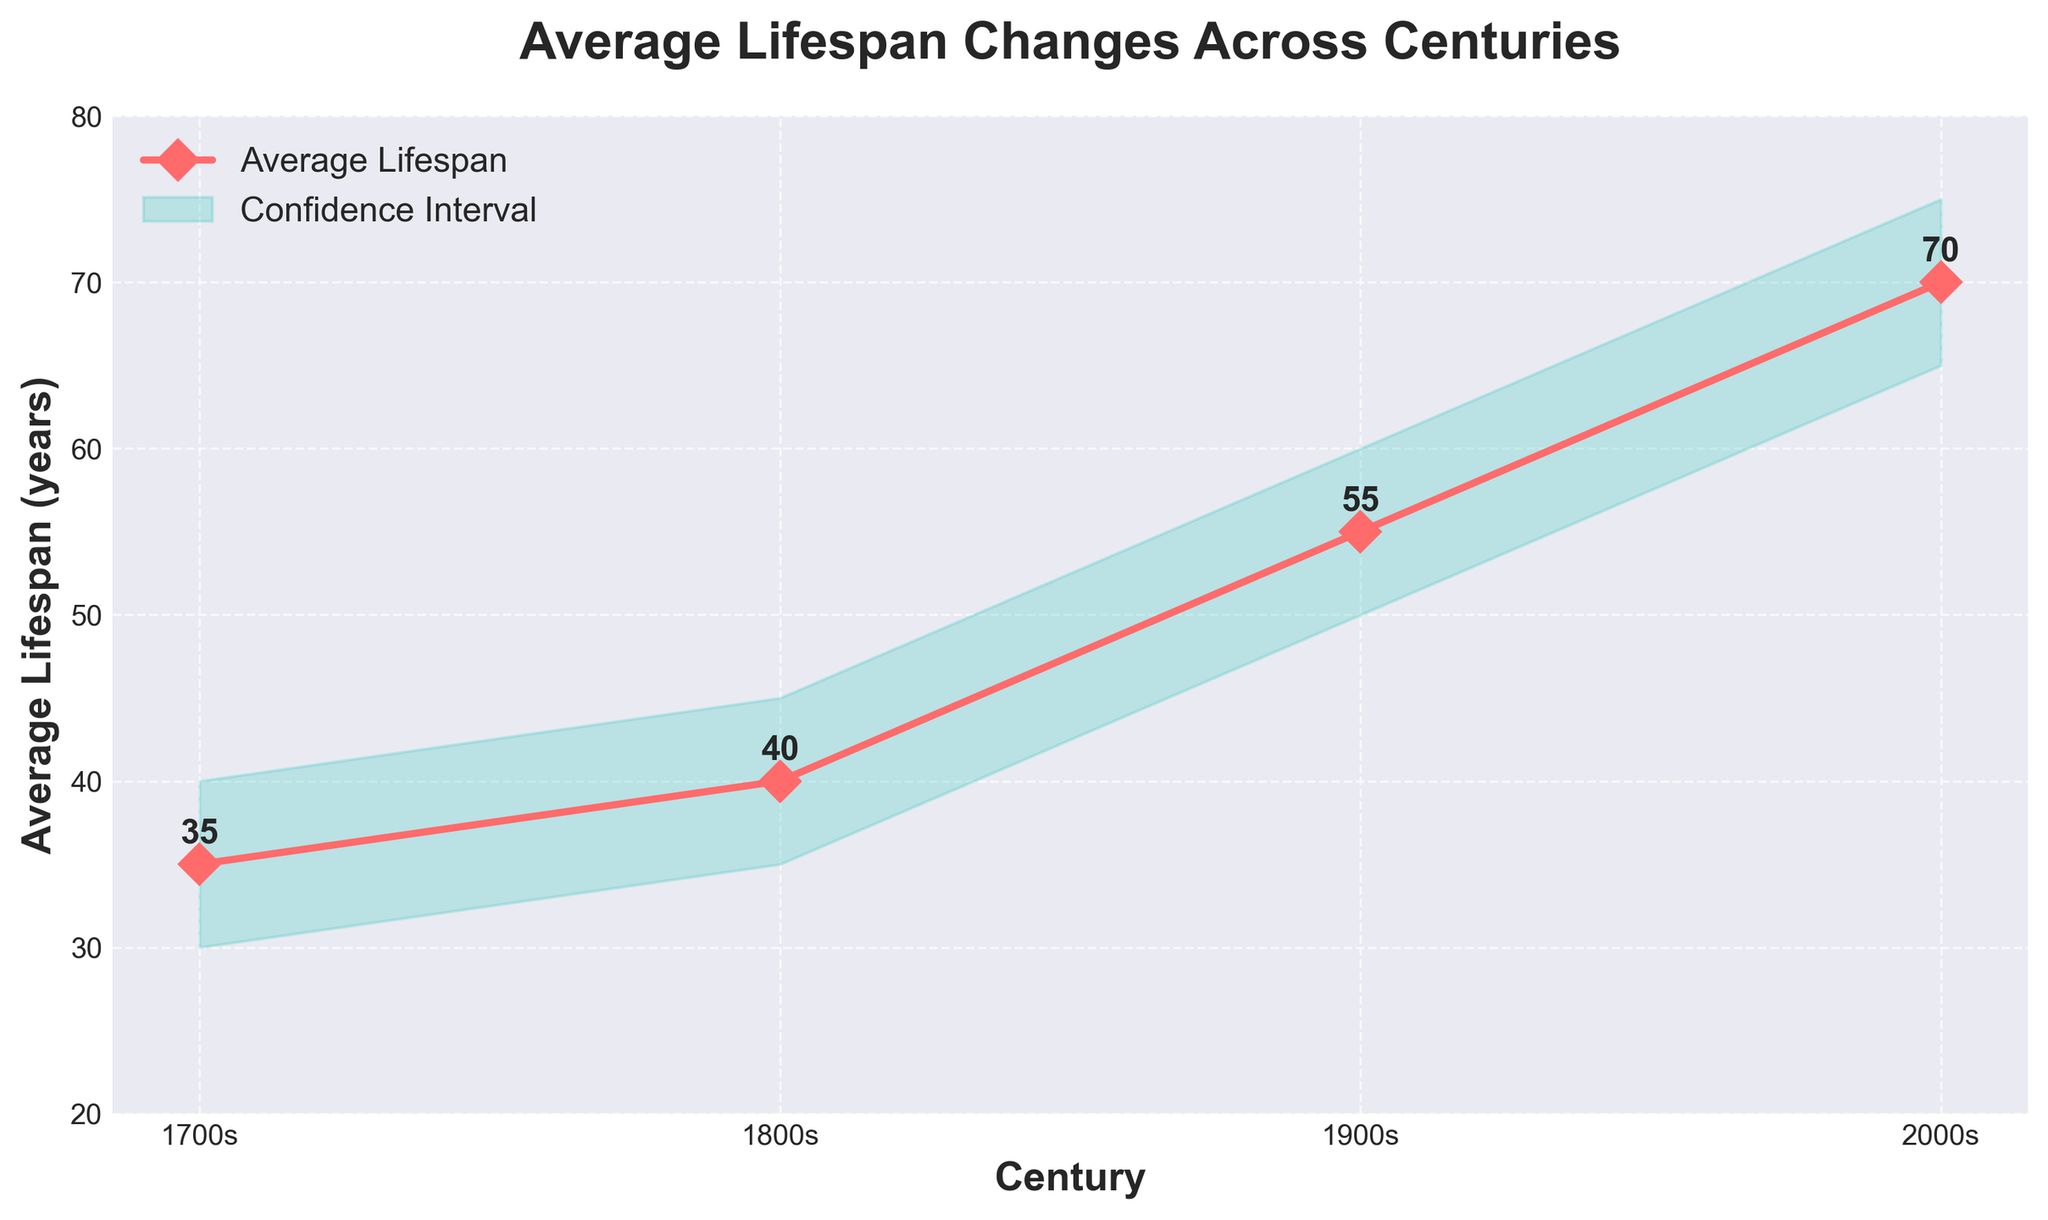What is the average lifespan in the 1900s? The y-axis represents the average lifespan in years. By locating the 1900s on the x-axis and looking at the corresponding point on the line, the average lifespan is found to be 55 years.
Answer: 55 What is the range of the confidence interval in the 1800s? To determine the range of the confidence interval in the 1800s, subtract the lower confidence interval from the upper confidence interval: 45 - 35.
Answer: 10 How much did the average lifespan increase from the 1700s to the 2000s? To find the increase in average lifespan from the 1700s to the 2000s, subtract the value in the 1700s from the value in the 2000s: 70 - 35.
Answer: 35 Which century has the lowest average lifespan? By comparing the points plotted on the line for each century, the 1700s have the lowest average lifespan of 35 years.
Answer: 1700s In which century is the confidence interval the widest? To find the widest confidence interval, compare the ranges (upper - lower) for each century. The 1700s have a range of 10, the 1800s have 10, the 1900s have 10, and the 2000s have 10. They are all equal in this case.
Answer: All centuries By how many years did the average lifespan increase from the 1800s to the 1900s? To find the increase in the average lifespan from the 1800s to the 1900s, subtract the value of the 1800s from the value of the 1900s: 55 - 40.
Answer: 15 What is the confidence interval for the average lifespan in the 2000s? The confidence interval can be read from the shaded area around the line at the 2000s, which ranges from 65 to 75.
Answer: 65 to 75 Which two centuries have the same confidence interval range? By subtracting the lower confidence interval from the upper confidence interval for each century: the 1700s have a range of 10 (40 - 30), the 1800s have 10 (45 - 35), the 1900s have 10 (60 - 50), and the 2000s have 10 (75 - 65). Therefore, all centuries have the same range.
Answer: All centuries Which century shows the greatest improvement in average lifespan compared to the previous one? By calculating the differences between consecutive centuries: the increase from 1700s to 1800s is 40 - 35 = 5, the increase from 1800s to 1900s is 55 - 40 = 15, and the increase from 1900s to 2000s is 70 - 55 = 15. The greatest improvements are from 1800s to 1900s and 1900s to 2000s, both showing an increase of 15 years.
Answer: 1800s to 1900s and 1900s to 2000s 